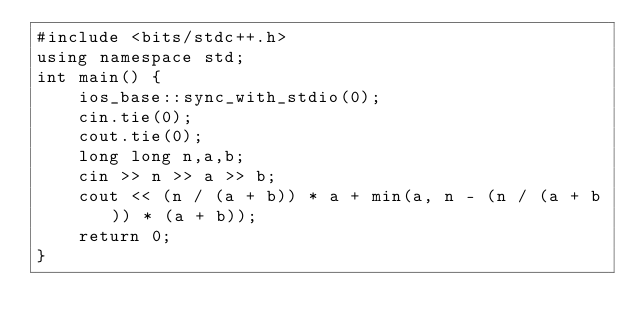<code> <loc_0><loc_0><loc_500><loc_500><_C++_>#include <bits/stdc++.h>
using namespace std;
int main() {
	ios_base::sync_with_stdio(0);
	cin.tie(0);
	cout.tie(0);
	long long n,a,b;
	cin >> n >> a >> b;
	cout << (n / (a + b)) * a + min(a, n - (n / (a + b)) * (a + b));	
	return 0;
}</code> 